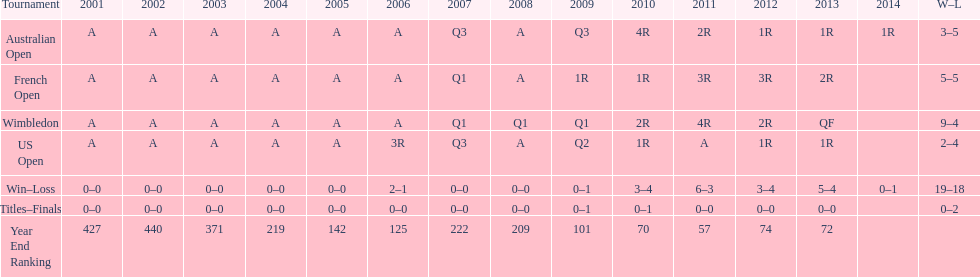What was this players ranking after 2005? 125. 